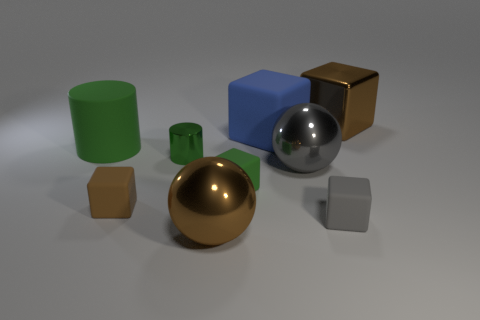Subtract all blue cubes. How many cubes are left? 4 Subtract all large rubber cubes. How many cubes are left? 4 Subtract 1 cubes. How many cubes are left? 4 Subtract all purple blocks. Subtract all cyan cylinders. How many blocks are left? 5 Subtract all blocks. How many objects are left? 4 Subtract 0 blue cylinders. How many objects are left? 9 Subtract all green shiny objects. Subtract all big gray shiny balls. How many objects are left? 7 Add 7 big gray objects. How many big gray objects are left? 8 Add 8 big blue cubes. How many big blue cubes exist? 9 